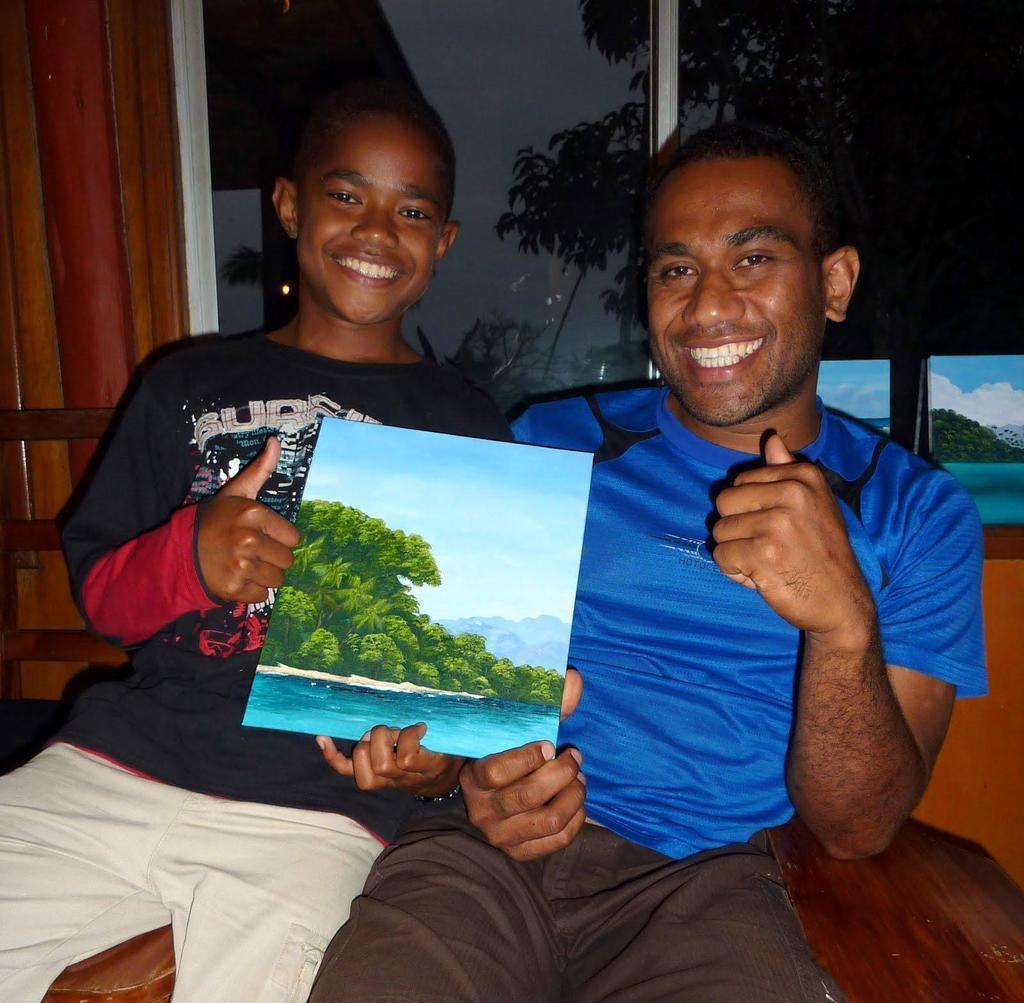How would you summarize this image in a sentence or two? In this picture we can see a man and a kid, they both are smiling and they are holding a poster. 